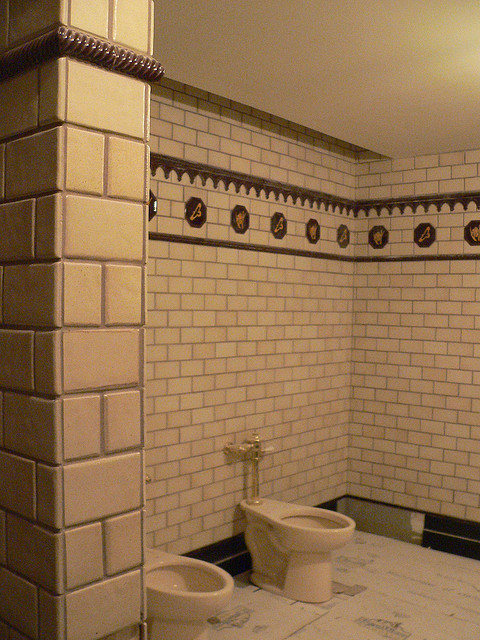<image>Is this a public bathroom? I am not sure if this is a public bathroom. However, majority of the responses suggest that it could be a public bathroom. What drawing is on the wall? It is unclear what drawing is on the wall. There might be none or it could be a triangle. Is this a public bathroom? I am not sure if this is a public bathroom. It can be both a public bathroom or not. What drawing is on the wall? There is no drawing on the wall. 